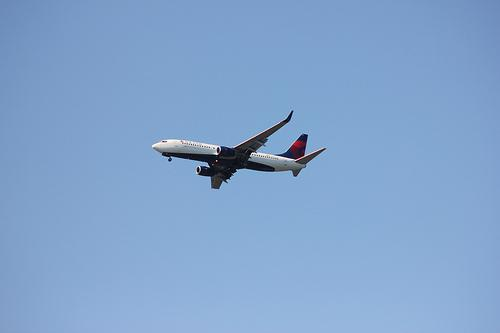Question: what vehicle is pictured?
Choices:
A. A car.
B. A motorcycle.
C. An airplane.
D. A motorboat.
Answer with the letter. Answer: C Question: what is the weather like?
Choices:
A. Rainy.
B. Snowy.
C. Sunny.
D. Clear.
Answer with the letter. Answer: D Question: how many engines does the airplane have?
Choices:
A. One.
B. Two.
C. Three.
D. Four.
Answer with the letter. Answer: B 